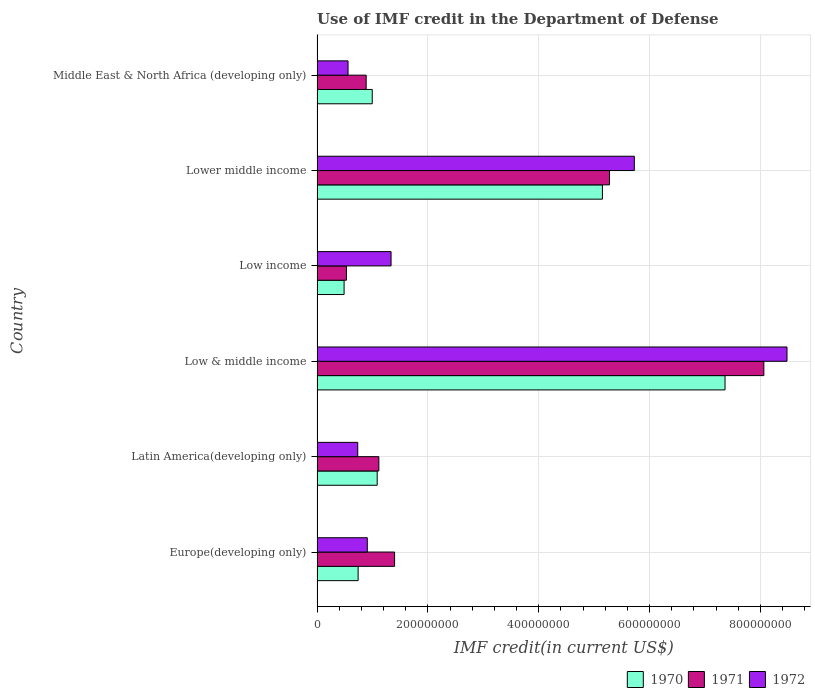How many different coloured bars are there?
Your answer should be very brief. 3. How many groups of bars are there?
Provide a succinct answer. 6. Are the number of bars per tick equal to the number of legend labels?
Your response must be concise. Yes. What is the label of the 3rd group of bars from the top?
Offer a very short reply. Low income. In how many cases, is the number of bars for a given country not equal to the number of legend labels?
Your answer should be very brief. 0. What is the IMF credit in the Department of Defense in 1970 in Lower middle income?
Your response must be concise. 5.15e+08. Across all countries, what is the maximum IMF credit in the Department of Defense in 1971?
Provide a short and direct response. 8.06e+08. Across all countries, what is the minimum IMF credit in the Department of Defense in 1970?
Keep it short and to the point. 4.88e+07. In which country was the IMF credit in the Department of Defense in 1971 maximum?
Your answer should be very brief. Low & middle income. What is the total IMF credit in the Department of Defense in 1970 in the graph?
Ensure brevity in your answer.  1.58e+09. What is the difference between the IMF credit in the Department of Defense in 1971 in Europe(developing only) and that in Middle East & North Africa (developing only)?
Your response must be concise. 5.13e+07. What is the difference between the IMF credit in the Department of Defense in 1971 in Middle East & North Africa (developing only) and the IMF credit in the Department of Defense in 1972 in Low & middle income?
Make the answer very short. -7.59e+08. What is the average IMF credit in the Department of Defense in 1970 per country?
Provide a succinct answer. 2.64e+08. What is the difference between the IMF credit in the Department of Defense in 1970 and IMF credit in the Department of Defense in 1971 in Latin America(developing only)?
Your answer should be compact. -3.01e+06. In how many countries, is the IMF credit in the Department of Defense in 1971 greater than 440000000 US$?
Your answer should be compact. 2. What is the ratio of the IMF credit in the Department of Defense in 1970 in Europe(developing only) to that in Low & middle income?
Ensure brevity in your answer.  0.1. Is the IMF credit in the Department of Defense in 1970 in Europe(developing only) less than that in Low income?
Give a very brief answer. No. Is the difference between the IMF credit in the Department of Defense in 1970 in Low & middle income and Lower middle income greater than the difference between the IMF credit in the Department of Defense in 1971 in Low & middle income and Lower middle income?
Provide a short and direct response. No. What is the difference between the highest and the second highest IMF credit in the Department of Defense in 1972?
Provide a succinct answer. 2.76e+08. What is the difference between the highest and the lowest IMF credit in the Department of Defense in 1970?
Your answer should be compact. 6.87e+08. In how many countries, is the IMF credit in the Department of Defense in 1971 greater than the average IMF credit in the Department of Defense in 1971 taken over all countries?
Give a very brief answer. 2. What does the 2nd bar from the bottom in Middle East & North Africa (developing only) represents?
Provide a succinct answer. 1971. Are the values on the major ticks of X-axis written in scientific E-notation?
Keep it short and to the point. No. Does the graph contain grids?
Your response must be concise. Yes. What is the title of the graph?
Offer a terse response. Use of IMF credit in the Department of Defense. What is the label or title of the X-axis?
Make the answer very short. IMF credit(in current US$). What is the IMF credit(in current US$) of 1970 in Europe(developing only)?
Offer a terse response. 7.41e+07. What is the IMF credit(in current US$) of 1971 in Europe(developing only)?
Your response must be concise. 1.40e+08. What is the IMF credit(in current US$) of 1972 in Europe(developing only)?
Make the answer very short. 9.07e+07. What is the IMF credit(in current US$) of 1970 in Latin America(developing only)?
Your answer should be compact. 1.09e+08. What is the IMF credit(in current US$) in 1971 in Latin America(developing only)?
Keep it short and to the point. 1.12e+08. What is the IMF credit(in current US$) of 1972 in Latin America(developing only)?
Your response must be concise. 7.34e+07. What is the IMF credit(in current US$) in 1970 in Low & middle income?
Offer a terse response. 7.36e+08. What is the IMF credit(in current US$) in 1971 in Low & middle income?
Ensure brevity in your answer.  8.06e+08. What is the IMF credit(in current US$) of 1972 in Low & middle income?
Your response must be concise. 8.48e+08. What is the IMF credit(in current US$) in 1970 in Low income?
Make the answer very short. 4.88e+07. What is the IMF credit(in current US$) of 1971 in Low income?
Provide a succinct answer. 5.30e+07. What is the IMF credit(in current US$) of 1972 in Low income?
Give a very brief answer. 1.34e+08. What is the IMF credit(in current US$) in 1970 in Lower middle income?
Keep it short and to the point. 5.15e+08. What is the IMF credit(in current US$) in 1971 in Lower middle income?
Keep it short and to the point. 5.28e+08. What is the IMF credit(in current US$) in 1972 in Lower middle income?
Your response must be concise. 5.73e+08. What is the IMF credit(in current US$) of 1970 in Middle East & North Africa (developing only)?
Ensure brevity in your answer.  9.96e+07. What is the IMF credit(in current US$) in 1971 in Middle East & North Africa (developing only)?
Give a very brief answer. 8.86e+07. What is the IMF credit(in current US$) in 1972 in Middle East & North Africa (developing only)?
Provide a succinct answer. 5.59e+07. Across all countries, what is the maximum IMF credit(in current US$) in 1970?
Offer a very short reply. 7.36e+08. Across all countries, what is the maximum IMF credit(in current US$) in 1971?
Keep it short and to the point. 8.06e+08. Across all countries, what is the maximum IMF credit(in current US$) of 1972?
Give a very brief answer. 8.48e+08. Across all countries, what is the minimum IMF credit(in current US$) in 1970?
Offer a terse response. 4.88e+07. Across all countries, what is the minimum IMF credit(in current US$) in 1971?
Make the answer very short. 5.30e+07. Across all countries, what is the minimum IMF credit(in current US$) in 1972?
Provide a succinct answer. 5.59e+07. What is the total IMF credit(in current US$) in 1970 in the graph?
Give a very brief answer. 1.58e+09. What is the total IMF credit(in current US$) of 1971 in the graph?
Keep it short and to the point. 1.73e+09. What is the total IMF credit(in current US$) in 1972 in the graph?
Provide a succinct answer. 1.77e+09. What is the difference between the IMF credit(in current US$) in 1970 in Europe(developing only) and that in Latin America(developing only)?
Ensure brevity in your answer.  -3.44e+07. What is the difference between the IMF credit(in current US$) in 1971 in Europe(developing only) and that in Latin America(developing only)?
Offer a very short reply. 2.84e+07. What is the difference between the IMF credit(in current US$) of 1972 in Europe(developing only) and that in Latin America(developing only)?
Provide a succinct answer. 1.72e+07. What is the difference between the IMF credit(in current US$) of 1970 in Europe(developing only) and that in Low & middle income?
Your answer should be compact. -6.62e+08. What is the difference between the IMF credit(in current US$) of 1971 in Europe(developing only) and that in Low & middle income?
Your answer should be compact. -6.66e+08. What is the difference between the IMF credit(in current US$) of 1972 in Europe(developing only) and that in Low & middle income?
Keep it short and to the point. -7.57e+08. What is the difference between the IMF credit(in current US$) in 1970 in Europe(developing only) and that in Low income?
Your response must be concise. 2.53e+07. What is the difference between the IMF credit(in current US$) of 1971 in Europe(developing only) and that in Low income?
Your answer should be compact. 8.69e+07. What is the difference between the IMF credit(in current US$) of 1972 in Europe(developing only) and that in Low income?
Ensure brevity in your answer.  -4.29e+07. What is the difference between the IMF credit(in current US$) in 1970 in Europe(developing only) and that in Lower middle income?
Ensure brevity in your answer.  -4.41e+08. What is the difference between the IMF credit(in current US$) in 1971 in Europe(developing only) and that in Lower middle income?
Give a very brief answer. -3.88e+08. What is the difference between the IMF credit(in current US$) of 1972 in Europe(developing only) and that in Lower middle income?
Keep it short and to the point. -4.82e+08. What is the difference between the IMF credit(in current US$) in 1970 in Europe(developing only) and that in Middle East & North Africa (developing only)?
Offer a very short reply. -2.55e+07. What is the difference between the IMF credit(in current US$) of 1971 in Europe(developing only) and that in Middle East & North Africa (developing only)?
Ensure brevity in your answer.  5.13e+07. What is the difference between the IMF credit(in current US$) of 1972 in Europe(developing only) and that in Middle East & North Africa (developing only)?
Offer a terse response. 3.47e+07. What is the difference between the IMF credit(in current US$) in 1970 in Latin America(developing only) and that in Low & middle income?
Offer a very short reply. -6.28e+08. What is the difference between the IMF credit(in current US$) in 1971 in Latin America(developing only) and that in Low & middle income?
Your answer should be compact. -6.95e+08. What is the difference between the IMF credit(in current US$) in 1972 in Latin America(developing only) and that in Low & middle income?
Ensure brevity in your answer.  -7.75e+08. What is the difference between the IMF credit(in current US$) in 1970 in Latin America(developing only) and that in Low income?
Make the answer very short. 5.97e+07. What is the difference between the IMF credit(in current US$) of 1971 in Latin America(developing only) and that in Low income?
Provide a short and direct response. 5.85e+07. What is the difference between the IMF credit(in current US$) in 1972 in Latin America(developing only) and that in Low income?
Make the answer very short. -6.01e+07. What is the difference between the IMF credit(in current US$) in 1970 in Latin America(developing only) and that in Lower middle income?
Ensure brevity in your answer.  -4.06e+08. What is the difference between the IMF credit(in current US$) of 1971 in Latin America(developing only) and that in Lower middle income?
Your answer should be very brief. -4.16e+08. What is the difference between the IMF credit(in current US$) of 1972 in Latin America(developing only) and that in Lower middle income?
Your answer should be very brief. -4.99e+08. What is the difference between the IMF credit(in current US$) in 1970 in Latin America(developing only) and that in Middle East & North Africa (developing only)?
Give a very brief answer. 8.90e+06. What is the difference between the IMF credit(in current US$) of 1971 in Latin America(developing only) and that in Middle East & North Africa (developing only)?
Offer a very short reply. 2.29e+07. What is the difference between the IMF credit(in current US$) of 1972 in Latin America(developing only) and that in Middle East & North Africa (developing only)?
Offer a very short reply. 1.75e+07. What is the difference between the IMF credit(in current US$) of 1970 in Low & middle income and that in Low income?
Your answer should be very brief. 6.87e+08. What is the difference between the IMF credit(in current US$) in 1971 in Low & middle income and that in Low income?
Provide a short and direct response. 7.53e+08. What is the difference between the IMF credit(in current US$) of 1972 in Low & middle income and that in Low income?
Your answer should be very brief. 7.14e+08. What is the difference between the IMF credit(in current US$) in 1970 in Low & middle income and that in Lower middle income?
Provide a succinct answer. 2.21e+08. What is the difference between the IMF credit(in current US$) in 1971 in Low & middle income and that in Lower middle income?
Your response must be concise. 2.79e+08. What is the difference between the IMF credit(in current US$) of 1972 in Low & middle income and that in Lower middle income?
Give a very brief answer. 2.76e+08. What is the difference between the IMF credit(in current US$) in 1970 in Low & middle income and that in Middle East & North Africa (developing only)?
Offer a terse response. 6.37e+08. What is the difference between the IMF credit(in current US$) in 1971 in Low & middle income and that in Middle East & North Africa (developing only)?
Make the answer very short. 7.18e+08. What is the difference between the IMF credit(in current US$) in 1972 in Low & middle income and that in Middle East & North Africa (developing only)?
Provide a succinct answer. 7.92e+08. What is the difference between the IMF credit(in current US$) of 1970 in Low income and that in Lower middle income?
Keep it short and to the point. -4.66e+08. What is the difference between the IMF credit(in current US$) in 1971 in Low income and that in Lower middle income?
Provide a short and direct response. -4.75e+08. What is the difference between the IMF credit(in current US$) of 1972 in Low income and that in Lower middle income?
Provide a succinct answer. -4.39e+08. What is the difference between the IMF credit(in current US$) of 1970 in Low income and that in Middle East & North Africa (developing only)?
Keep it short and to the point. -5.08e+07. What is the difference between the IMF credit(in current US$) of 1971 in Low income and that in Middle East & North Africa (developing only)?
Your answer should be compact. -3.56e+07. What is the difference between the IMF credit(in current US$) of 1972 in Low income and that in Middle East & North Africa (developing only)?
Give a very brief answer. 7.76e+07. What is the difference between the IMF credit(in current US$) of 1970 in Lower middle income and that in Middle East & North Africa (developing only)?
Give a very brief answer. 4.15e+08. What is the difference between the IMF credit(in current US$) in 1971 in Lower middle income and that in Middle East & North Africa (developing only)?
Your answer should be very brief. 4.39e+08. What is the difference between the IMF credit(in current US$) in 1972 in Lower middle income and that in Middle East & North Africa (developing only)?
Your answer should be very brief. 5.17e+08. What is the difference between the IMF credit(in current US$) in 1970 in Europe(developing only) and the IMF credit(in current US$) in 1971 in Latin America(developing only)?
Offer a terse response. -3.74e+07. What is the difference between the IMF credit(in current US$) in 1970 in Europe(developing only) and the IMF credit(in current US$) in 1972 in Latin America(developing only)?
Your answer should be very brief. 7.05e+05. What is the difference between the IMF credit(in current US$) of 1971 in Europe(developing only) and the IMF credit(in current US$) of 1972 in Latin America(developing only)?
Ensure brevity in your answer.  6.65e+07. What is the difference between the IMF credit(in current US$) of 1970 in Europe(developing only) and the IMF credit(in current US$) of 1971 in Low & middle income?
Give a very brief answer. -7.32e+08. What is the difference between the IMF credit(in current US$) of 1970 in Europe(developing only) and the IMF credit(in current US$) of 1972 in Low & middle income?
Give a very brief answer. -7.74e+08. What is the difference between the IMF credit(in current US$) in 1971 in Europe(developing only) and the IMF credit(in current US$) in 1972 in Low & middle income?
Provide a succinct answer. -7.08e+08. What is the difference between the IMF credit(in current US$) in 1970 in Europe(developing only) and the IMF credit(in current US$) in 1971 in Low income?
Provide a short and direct response. 2.11e+07. What is the difference between the IMF credit(in current US$) in 1970 in Europe(developing only) and the IMF credit(in current US$) in 1972 in Low income?
Make the answer very short. -5.94e+07. What is the difference between the IMF credit(in current US$) of 1971 in Europe(developing only) and the IMF credit(in current US$) of 1972 in Low income?
Keep it short and to the point. 6.35e+06. What is the difference between the IMF credit(in current US$) of 1970 in Europe(developing only) and the IMF credit(in current US$) of 1971 in Lower middle income?
Your response must be concise. -4.54e+08. What is the difference between the IMF credit(in current US$) of 1970 in Europe(developing only) and the IMF credit(in current US$) of 1972 in Lower middle income?
Ensure brevity in your answer.  -4.98e+08. What is the difference between the IMF credit(in current US$) in 1971 in Europe(developing only) and the IMF credit(in current US$) in 1972 in Lower middle income?
Your answer should be very brief. -4.33e+08. What is the difference between the IMF credit(in current US$) in 1970 in Europe(developing only) and the IMF credit(in current US$) in 1971 in Middle East & North Africa (developing only)?
Provide a succinct answer. -1.45e+07. What is the difference between the IMF credit(in current US$) of 1970 in Europe(developing only) and the IMF credit(in current US$) of 1972 in Middle East & North Africa (developing only)?
Provide a short and direct response. 1.82e+07. What is the difference between the IMF credit(in current US$) of 1971 in Europe(developing only) and the IMF credit(in current US$) of 1972 in Middle East & North Africa (developing only)?
Your answer should be very brief. 8.40e+07. What is the difference between the IMF credit(in current US$) of 1970 in Latin America(developing only) and the IMF credit(in current US$) of 1971 in Low & middle income?
Offer a terse response. -6.98e+08. What is the difference between the IMF credit(in current US$) of 1970 in Latin America(developing only) and the IMF credit(in current US$) of 1972 in Low & middle income?
Keep it short and to the point. -7.40e+08. What is the difference between the IMF credit(in current US$) of 1971 in Latin America(developing only) and the IMF credit(in current US$) of 1972 in Low & middle income?
Your answer should be very brief. -7.37e+08. What is the difference between the IMF credit(in current US$) in 1970 in Latin America(developing only) and the IMF credit(in current US$) in 1971 in Low income?
Ensure brevity in your answer.  5.55e+07. What is the difference between the IMF credit(in current US$) of 1970 in Latin America(developing only) and the IMF credit(in current US$) of 1972 in Low income?
Give a very brief answer. -2.50e+07. What is the difference between the IMF credit(in current US$) of 1971 in Latin America(developing only) and the IMF credit(in current US$) of 1972 in Low income?
Your answer should be compact. -2.20e+07. What is the difference between the IMF credit(in current US$) of 1970 in Latin America(developing only) and the IMF credit(in current US$) of 1971 in Lower middle income?
Ensure brevity in your answer.  -4.19e+08. What is the difference between the IMF credit(in current US$) of 1970 in Latin America(developing only) and the IMF credit(in current US$) of 1972 in Lower middle income?
Provide a succinct answer. -4.64e+08. What is the difference between the IMF credit(in current US$) of 1971 in Latin America(developing only) and the IMF credit(in current US$) of 1972 in Lower middle income?
Offer a terse response. -4.61e+08. What is the difference between the IMF credit(in current US$) in 1970 in Latin America(developing only) and the IMF credit(in current US$) in 1971 in Middle East & North Africa (developing only)?
Give a very brief answer. 1.99e+07. What is the difference between the IMF credit(in current US$) of 1970 in Latin America(developing only) and the IMF credit(in current US$) of 1972 in Middle East & North Africa (developing only)?
Offer a terse response. 5.26e+07. What is the difference between the IMF credit(in current US$) of 1971 in Latin America(developing only) and the IMF credit(in current US$) of 1972 in Middle East & North Africa (developing only)?
Offer a very short reply. 5.56e+07. What is the difference between the IMF credit(in current US$) of 1970 in Low & middle income and the IMF credit(in current US$) of 1971 in Low income?
Make the answer very short. 6.83e+08. What is the difference between the IMF credit(in current US$) in 1970 in Low & middle income and the IMF credit(in current US$) in 1972 in Low income?
Keep it short and to the point. 6.03e+08. What is the difference between the IMF credit(in current US$) in 1971 in Low & middle income and the IMF credit(in current US$) in 1972 in Low income?
Make the answer very short. 6.73e+08. What is the difference between the IMF credit(in current US$) of 1970 in Low & middle income and the IMF credit(in current US$) of 1971 in Lower middle income?
Offer a very short reply. 2.08e+08. What is the difference between the IMF credit(in current US$) of 1970 in Low & middle income and the IMF credit(in current US$) of 1972 in Lower middle income?
Give a very brief answer. 1.64e+08. What is the difference between the IMF credit(in current US$) in 1971 in Low & middle income and the IMF credit(in current US$) in 1972 in Lower middle income?
Give a very brief answer. 2.34e+08. What is the difference between the IMF credit(in current US$) in 1970 in Low & middle income and the IMF credit(in current US$) in 1971 in Middle East & North Africa (developing only)?
Provide a succinct answer. 6.48e+08. What is the difference between the IMF credit(in current US$) of 1970 in Low & middle income and the IMF credit(in current US$) of 1972 in Middle East & North Africa (developing only)?
Make the answer very short. 6.80e+08. What is the difference between the IMF credit(in current US$) in 1971 in Low & middle income and the IMF credit(in current US$) in 1972 in Middle East & North Africa (developing only)?
Your response must be concise. 7.50e+08. What is the difference between the IMF credit(in current US$) of 1970 in Low income and the IMF credit(in current US$) of 1971 in Lower middle income?
Provide a short and direct response. -4.79e+08. What is the difference between the IMF credit(in current US$) of 1970 in Low income and the IMF credit(in current US$) of 1972 in Lower middle income?
Your answer should be very brief. -5.24e+08. What is the difference between the IMF credit(in current US$) in 1971 in Low income and the IMF credit(in current US$) in 1972 in Lower middle income?
Offer a very short reply. -5.20e+08. What is the difference between the IMF credit(in current US$) of 1970 in Low income and the IMF credit(in current US$) of 1971 in Middle East & North Africa (developing only)?
Your answer should be compact. -3.98e+07. What is the difference between the IMF credit(in current US$) of 1970 in Low income and the IMF credit(in current US$) of 1972 in Middle East & North Africa (developing only)?
Your response must be concise. -7.12e+06. What is the difference between the IMF credit(in current US$) of 1971 in Low income and the IMF credit(in current US$) of 1972 in Middle East & North Africa (developing only)?
Provide a succinct answer. -2.90e+06. What is the difference between the IMF credit(in current US$) of 1970 in Lower middle income and the IMF credit(in current US$) of 1971 in Middle East & North Africa (developing only)?
Provide a short and direct response. 4.26e+08. What is the difference between the IMF credit(in current US$) in 1970 in Lower middle income and the IMF credit(in current US$) in 1972 in Middle East & North Africa (developing only)?
Ensure brevity in your answer.  4.59e+08. What is the difference between the IMF credit(in current US$) in 1971 in Lower middle income and the IMF credit(in current US$) in 1972 in Middle East & North Africa (developing only)?
Provide a short and direct response. 4.72e+08. What is the average IMF credit(in current US$) of 1970 per country?
Provide a succinct answer. 2.64e+08. What is the average IMF credit(in current US$) in 1971 per country?
Provide a succinct answer. 2.88e+08. What is the average IMF credit(in current US$) in 1972 per country?
Your answer should be very brief. 2.96e+08. What is the difference between the IMF credit(in current US$) of 1970 and IMF credit(in current US$) of 1971 in Europe(developing only)?
Make the answer very short. -6.58e+07. What is the difference between the IMF credit(in current US$) in 1970 and IMF credit(in current US$) in 1972 in Europe(developing only)?
Your response must be concise. -1.65e+07. What is the difference between the IMF credit(in current US$) of 1971 and IMF credit(in current US$) of 1972 in Europe(developing only)?
Provide a succinct answer. 4.93e+07. What is the difference between the IMF credit(in current US$) of 1970 and IMF credit(in current US$) of 1971 in Latin America(developing only)?
Your response must be concise. -3.01e+06. What is the difference between the IMF credit(in current US$) in 1970 and IMF credit(in current US$) in 1972 in Latin America(developing only)?
Your answer should be very brief. 3.51e+07. What is the difference between the IMF credit(in current US$) of 1971 and IMF credit(in current US$) of 1972 in Latin America(developing only)?
Your answer should be compact. 3.81e+07. What is the difference between the IMF credit(in current US$) of 1970 and IMF credit(in current US$) of 1971 in Low & middle income?
Make the answer very short. -7.00e+07. What is the difference between the IMF credit(in current US$) in 1970 and IMF credit(in current US$) in 1972 in Low & middle income?
Your response must be concise. -1.12e+08. What is the difference between the IMF credit(in current US$) of 1971 and IMF credit(in current US$) of 1972 in Low & middle income?
Provide a succinct answer. -4.18e+07. What is the difference between the IMF credit(in current US$) in 1970 and IMF credit(in current US$) in 1971 in Low income?
Provide a succinct answer. -4.21e+06. What is the difference between the IMF credit(in current US$) of 1970 and IMF credit(in current US$) of 1972 in Low income?
Ensure brevity in your answer.  -8.47e+07. What is the difference between the IMF credit(in current US$) in 1971 and IMF credit(in current US$) in 1972 in Low income?
Your answer should be very brief. -8.05e+07. What is the difference between the IMF credit(in current US$) of 1970 and IMF credit(in current US$) of 1971 in Lower middle income?
Offer a very short reply. -1.28e+07. What is the difference between the IMF credit(in current US$) in 1970 and IMF credit(in current US$) in 1972 in Lower middle income?
Give a very brief answer. -5.76e+07. What is the difference between the IMF credit(in current US$) in 1971 and IMF credit(in current US$) in 1972 in Lower middle income?
Ensure brevity in your answer.  -4.48e+07. What is the difference between the IMF credit(in current US$) of 1970 and IMF credit(in current US$) of 1971 in Middle East & North Africa (developing only)?
Provide a short and direct response. 1.10e+07. What is the difference between the IMF credit(in current US$) in 1970 and IMF credit(in current US$) in 1972 in Middle East & North Africa (developing only)?
Your answer should be compact. 4.37e+07. What is the difference between the IMF credit(in current US$) in 1971 and IMF credit(in current US$) in 1972 in Middle East & North Africa (developing only)?
Make the answer very short. 3.27e+07. What is the ratio of the IMF credit(in current US$) of 1970 in Europe(developing only) to that in Latin America(developing only)?
Ensure brevity in your answer.  0.68. What is the ratio of the IMF credit(in current US$) of 1971 in Europe(developing only) to that in Latin America(developing only)?
Offer a terse response. 1.25. What is the ratio of the IMF credit(in current US$) in 1972 in Europe(developing only) to that in Latin America(developing only)?
Give a very brief answer. 1.23. What is the ratio of the IMF credit(in current US$) of 1970 in Europe(developing only) to that in Low & middle income?
Offer a very short reply. 0.1. What is the ratio of the IMF credit(in current US$) in 1971 in Europe(developing only) to that in Low & middle income?
Your answer should be very brief. 0.17. What is the ratio of the IMF credit(in current US$) in 1972 in Europe(developing only) to that in Low & middle income?
Your answer should be compact. 0.11. What is the ratio of the IMF credit(in current US$) of 1970 in Europe(developing only) to that in Low income?
Your response must be concise. 1.52. What is the ratio of the IMF credit(in current US$) in 1971 in Europe(developing only) to that in Low income?
Offer a very short reply. 2.64. What is the ratio of the IMF credit(in current US$) of 1972 in Europe(developing only) to that in Low income?
Make the answer very short. 0.68. What is the ratio of the IMF credit(in current US$) in 1970 in Europe(developing only) to that in Lower middle income?
Your answer should be very brief. 0.14. What is the ratio of the IMF credit(in current US$) in 1971 in Europe(developing only) to that in Lower middle income?
Provide a succinct answer. 0.27. What is the ratio of the IMF credit(in current US$) of 1972 in Europe(developing only) to that in Lower middle income?
Give a very brief answer. 0.16. What is the ratio of the IMF credit(in current US$) in 1970 in Europe(developing only) to that in Middle East & North Africa (developing only)?
Keep it short and to the point. 0.74. What is the ratio of the IMF credit(in current US$) of 1971 in Europe(developing only) to that in Middle East & North Africa (developing only)?
Offer a terse response. 1.58. What is the ratio of the IMF credit(in current US$) in 1972 in Europe(developing only) to that in Middle East & North Africa (developing only)?
Keep it short and to the point. 1.62. What is the ratio of the IMF credit(in current US$) of 1970 in Latin America(developing only) to that in Low & middle income?
Your answer should be very brief. 0.15. What is the ratio of the IMF credit(in current US$) of 1971 in Latin America(developing only) to that in Low & middle income?
Offer a terse response. 0.14. What is the ratio of the IMF credit(in current US$) in 1972 in Latin America(developing only) to that in Low & middle income?
Your response must be concise. 0.09. What is the ratio of the IMF credit(in current US$) in 1970 in Latin America(developing only) to that in Low income?
Provide a succinct answer. 2.22. What is the ratio of the IMF credit(in current US$) in 1971 in Latin America(developing only) to that in Low income?
Your answer should be compact. 2.1. What is the ratio of the IMF credit(in current US$) in 1972 in Latin America(developing only) to that in Low income?
Keep it short and to the point. 0.55. What is the ratio of the IMF credit(in current US$) in 1970 in Latin America(developing only) to that in Lower middle income?
Ensure brevity in your answer.  0.21. What is the ratio of the IMF credit(in current US$) of 1971 in Latin America(developing only) to that in Lower middle income?
Provide a short and direct response. 0.21. What is the ratio of the IMF credit(in current US$) in 1972 in Latin America(developing only) to that in Lower middle income?
Make the answer very short. 0.13. What is the ratio of the IMF credit(in current US$) in 1970 in Latin America(developing only) to that in Middle East & North Africa (developing only)?
Make the answer very short. 1.09. What is the ratio of the IMF credit(in current US$) of 1971 in Latin America(developing only) to that in Middle East & North Africa (developing only)?
Your response must be concise. 1.26. What is the ratio of the IMF credit(in current US$) of 1972 in Latin America(developing only) to that in Middle East & North Africa (developing only)?
Offer a terse response. 1.31. What is the ratio of the IMF credit(in current US$) in 1970 in Low & middle income to that in Low income?
Keep it short and to the point. 15.08. What is the ratio of the IMF credit(in current US$) in 1971 in Low & middle income to that in Low income?
Make the answer very short. 15.21. What is the ratio of the IMF credit(in current US$) of 1972 in Low & middle income to that in Low income?
Provide a succinct answer. 6.35. What is the ratio of the IMF credit(in current US$) of 1970 in Low & middle income to that in Lower middle income?
Your response must be concise. 1.43. What is the ratio of the IMF credit(in current US$) in 1971 in Low & middle income to that in Lower middle income?
Ensure brevity in your answer.  1.53. What is the ratio of the IMF credit(in current US$) of 1972 in Low & middle income to that in Lower middle income?
Provide a succinct answer. 1.48. What is the ratio of the IMF credit(in current US$) of 1970 in Low & middle income to that in Middle East & North Africa (developing only)?
Provide a succinct answer. 7.39. What is the ratio of the IMF credit(in current US$) of 1971 in Low & middle income to that in Middle East & North Africa (developing only)?
Your answer should be very brief. 9.1. What is the ratio of the IMF credit(in current US$) in 1972 in Low & middle income to that in Middle East & North Africa (developing only)?
Provide a succinct answer. 15.16. What is the ratio of the IMF credit(in current US$) of 1970 in Low income to that in Lower middle income?
Ensure brevity in your answer.  0.09. What is the ratio of the IMF credit(in current US$) in 1971 in Low income to that in Lower middle income?
Ensure brevity in your answer.  0.1. What is the ratio of the IMF credit(in current US$) in 1972 in Low income to that in Lower middle income?
Ensure brevity in your answer.  0.23. What is the ratio of the IMF credit(in current US$) in 1970 in Low income to that in Middle East & North Africa (developing only)?
Give a very brief answer. 0.49. What is the ratio of the IMF credit(in current US$) in 1971 in Low income to that in Middle East & North Africa (developing only)?
Provide a short and direct response. 0.6. What is the ratio of the IMF credit(in current US$) in 1972 in Low income to that in Middle East & North Africa (developing only)?
Your response must be concise. 2.39. What is the ratio of the IMF credit(in current US$) in 1970 in Lower middle income to that in Middle East & North Africa (developing only)?
Make the answer very short. 5.17. What is the ratio of the IMF credit(in current US$) of 1971 in Lower middle income to that in Middle East & North Africa (developing only)?
Offer a terse response. 5.95. What is the ratio of the IMF credit(in current US$) of 1972 in Lower middle income to that in Middle East & North Africa (developing only)?
Your answer should be very brief. 10.24. What is the difference between the highest and the second highest IMF credit(in current US$) of 1970?
Offer a very short reply. 2.21e+08. What is the difference between the highest and the second highest IMF credit(in current US$) of 1971?
Make the answer very short. 2.79e+08. What is the difference between the highest and the second highest IMF credit(in current US$) of 1972?
Your answer should be very brief. 2.76e+08. What is the difference between the highest and the lowest IMF credit(in current US$) of 1970?
Make the answer very short. 6.87e+08. What is the difference between the highest and the lowest IMF credit(in current US$) in 1971?
Your response must be concise. 7.53e+08. What is the difference between the highest and the lowest IMF credit(in current US$) of 1972?
Provide a short and direct response. 7.92e+08. 